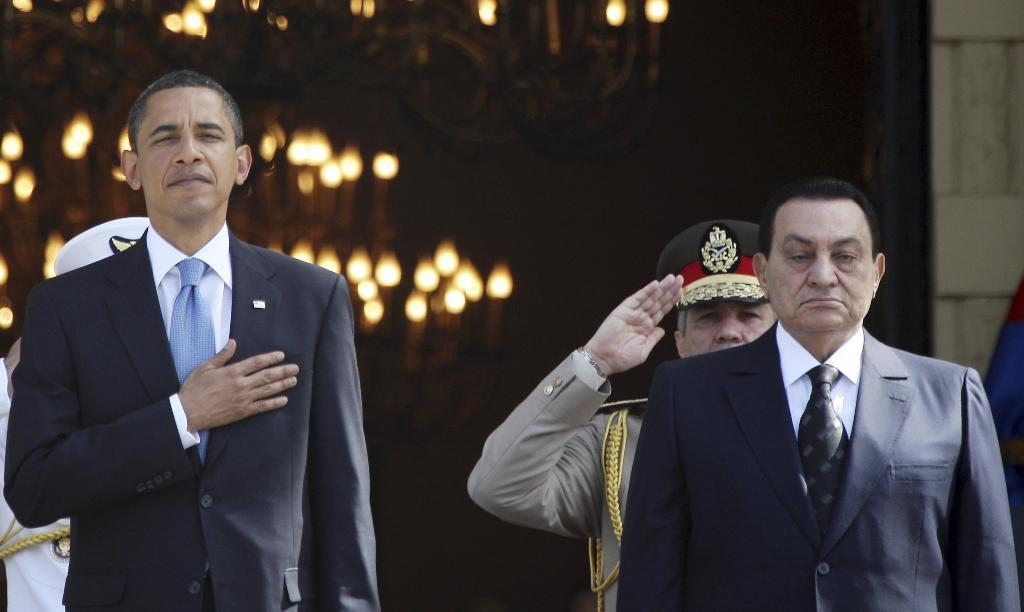How many people are in the foreground of the image? There are four persons standing in the foreground of the image. What can be seen in the background of the image? There is a wall, lights, and chandeliers in the background of the image. When was the image taken? The image was taken during the day. What value does the beginner dad place on the chandeliers in the image? There is no information about a beginner dad or their values in the image, as it only shows four persons standing in the foreground and a wall, lights, and chandeliers in the background. 